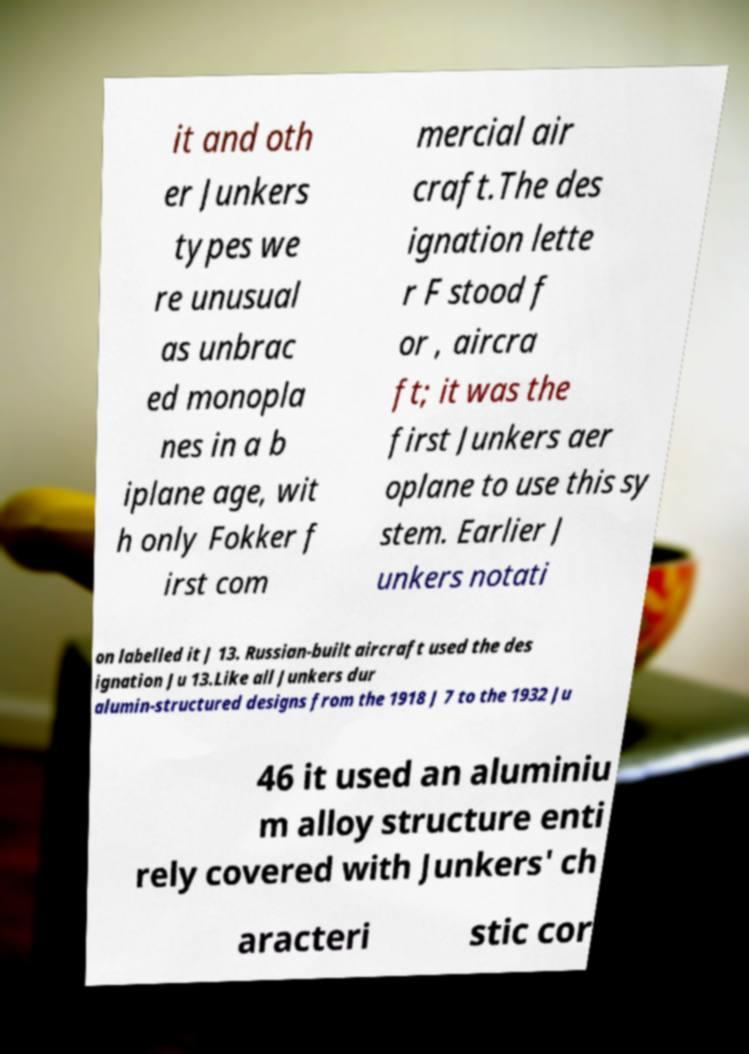Please read and relay the text visible in this image. What does it say? it and oth er Junkers types we re unusual as unbrac ed monopla nes in a b iplane age, wit h only Fokker f irst com mercial air craft.The des ignation lette r F stood f or , aircra ft; it was the first Junkers aer oplane to use this sy stem. Earlier J unkers notati on labelled it J 13. Russian-built aircraft used the des ignation Ju 13.Like all Junkers dur alumin-structured designs from the 1918 J 7 to the 1932 Ju 46 it used an aluminiu m alloy structure enti rely covered with Junkers' ch aracteri stic cor 